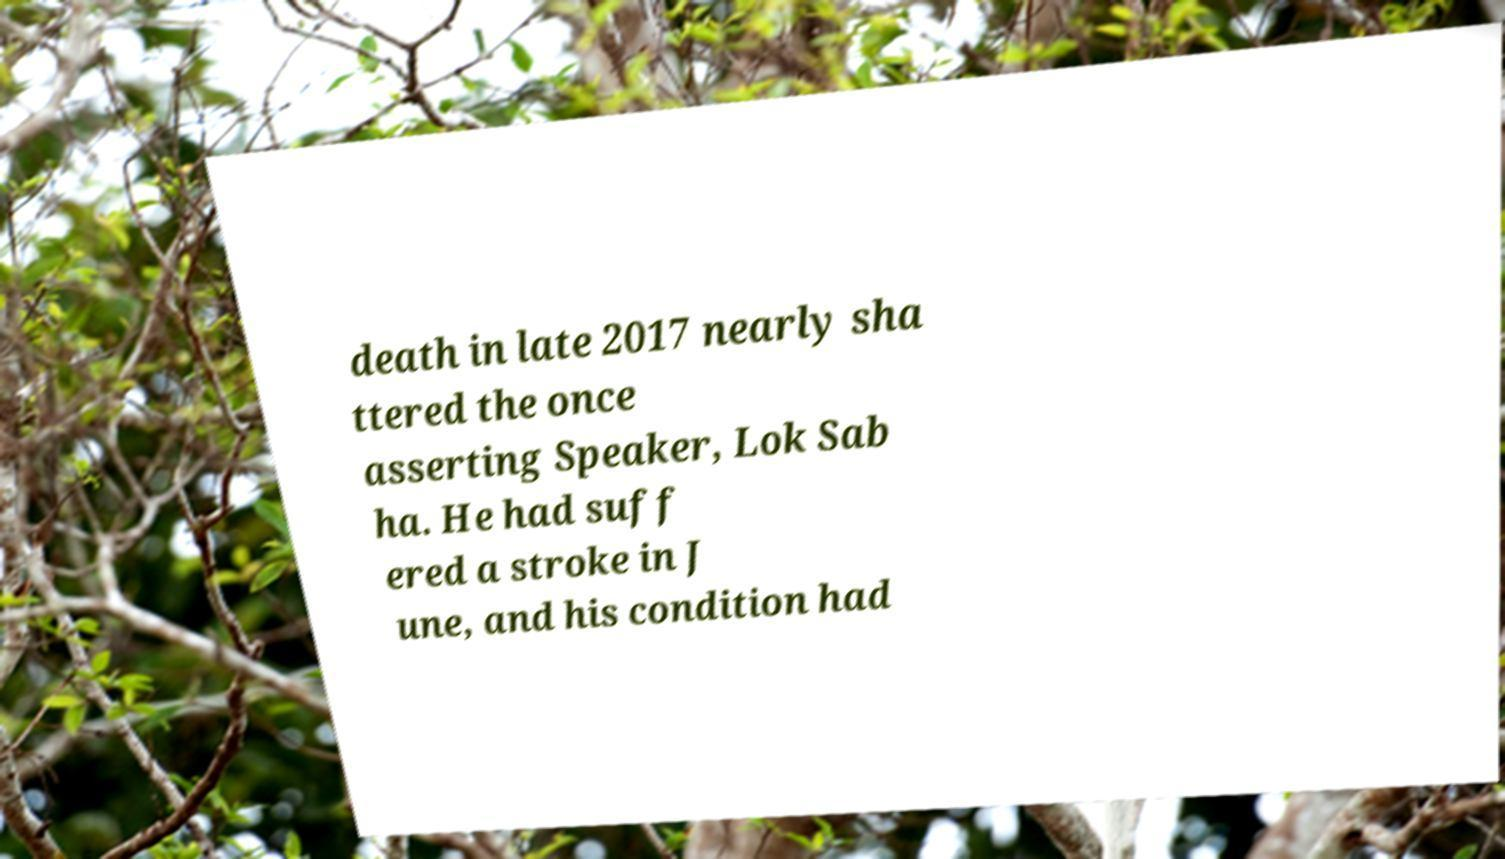Could you assist in decoding the text presented in this image and type it out clearly? death in late 2017 nearly sha ttered the once asserting Speaker, Lok Sab ha. He had suff ered a stroke in J une, and his condition had 